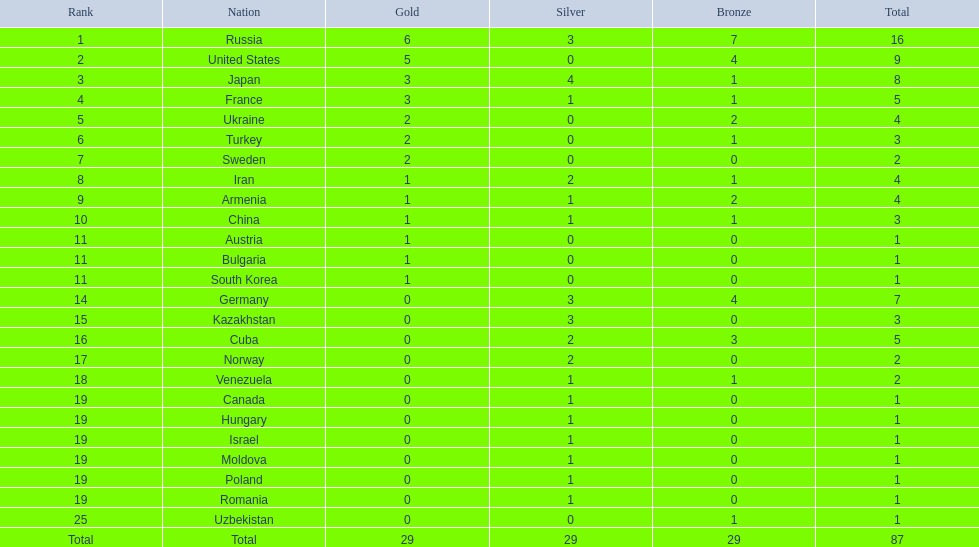What rank did iran achieve? 8. What rank did germany achieve? 14. Between iran and germany, which country did not secure a spot in the top 10? Germany. 